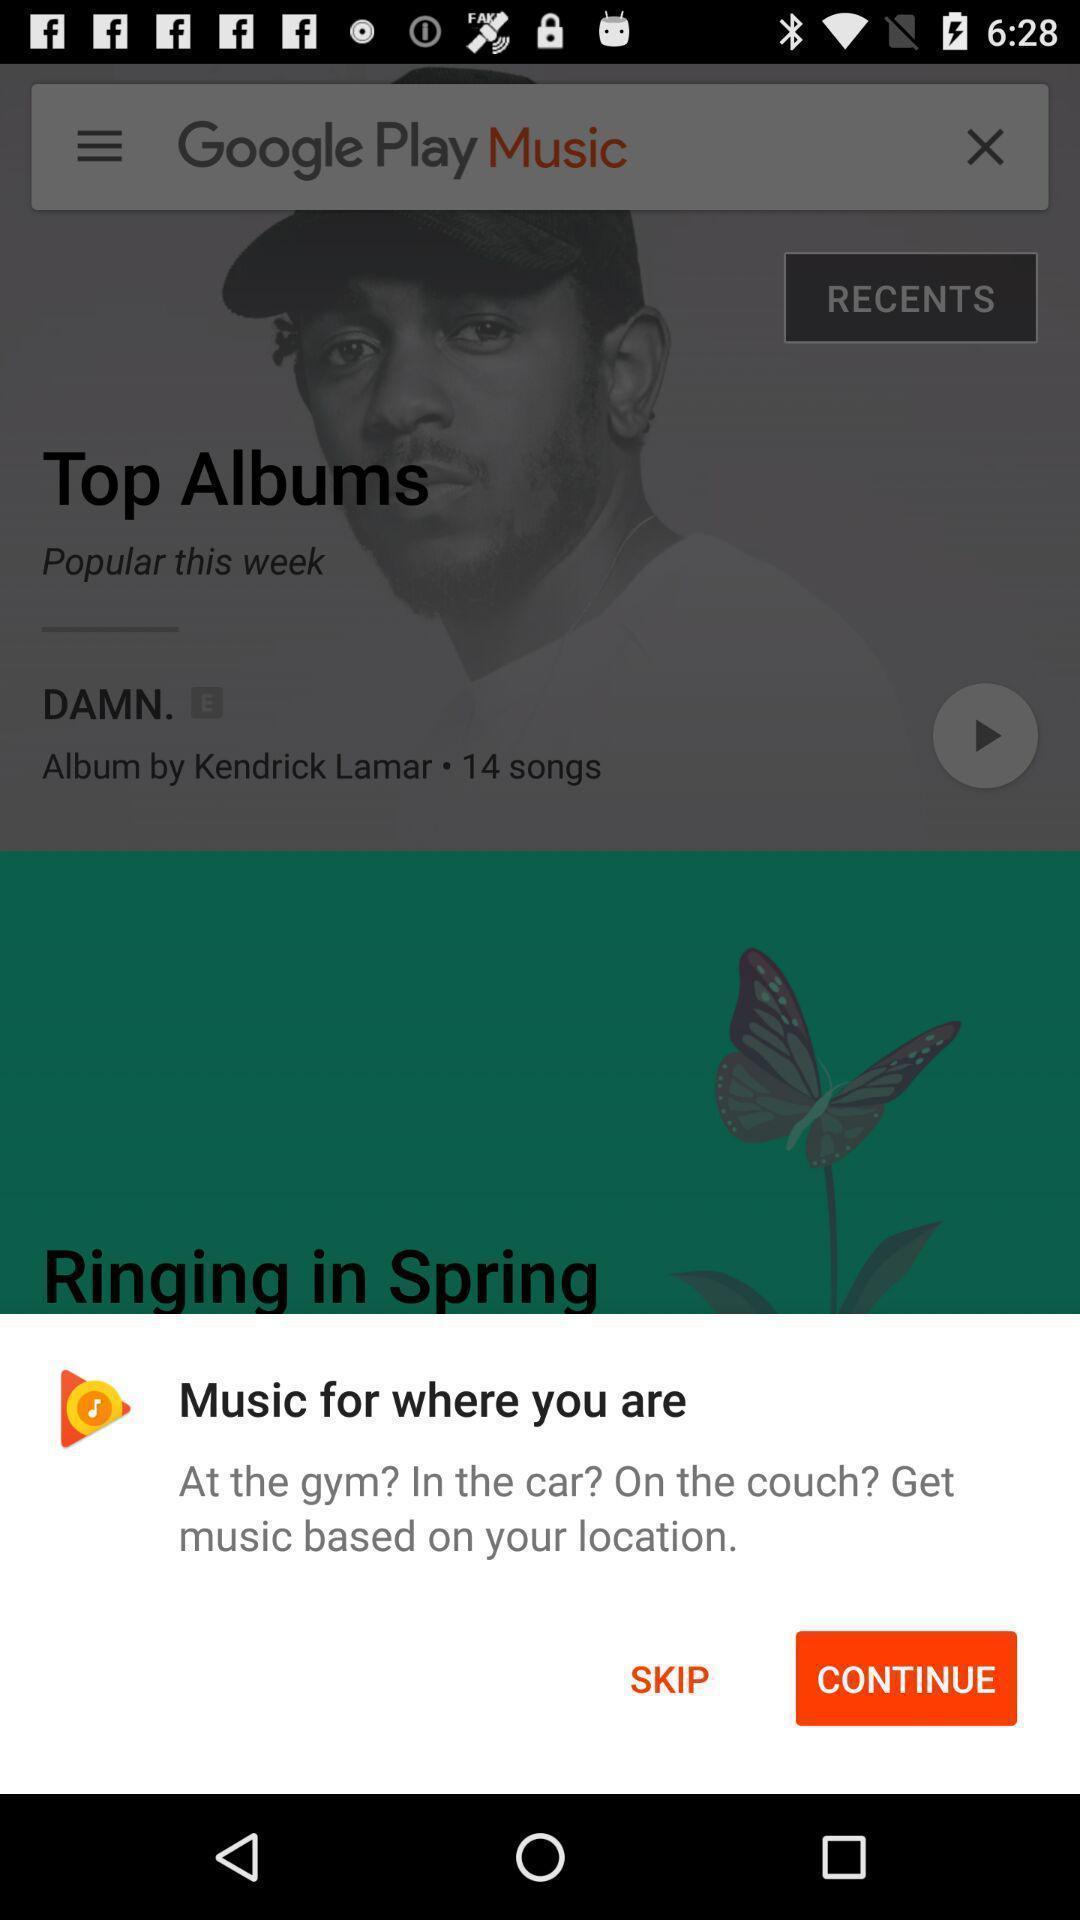Explain what's happening in this screen capture. Push up page showing app preference to open. 